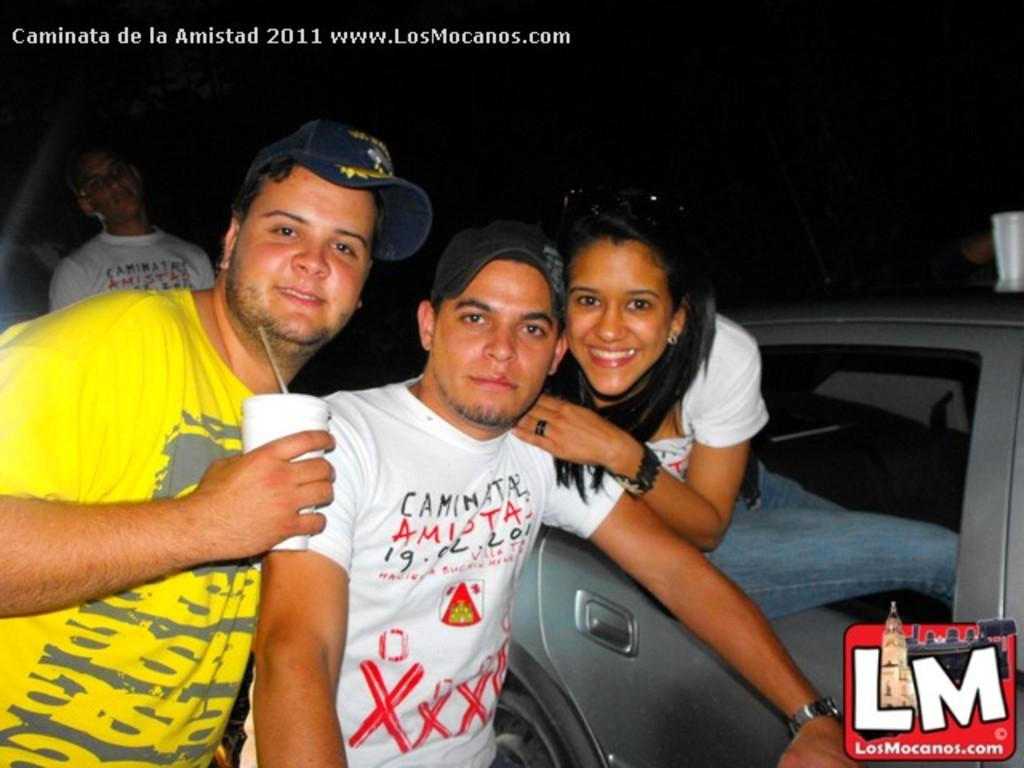How many people are present in the image? There are two men standing in the image. What is the woman in the image doing? The woman is sitting in a car. Can you describe the background of the image? In the background, there is a man visible. What type of star can be seen in the image? There is no star visible in the image. What kind of seed is being planted by the woman in the image? The woman is sitting in a car, not planting seeds. 